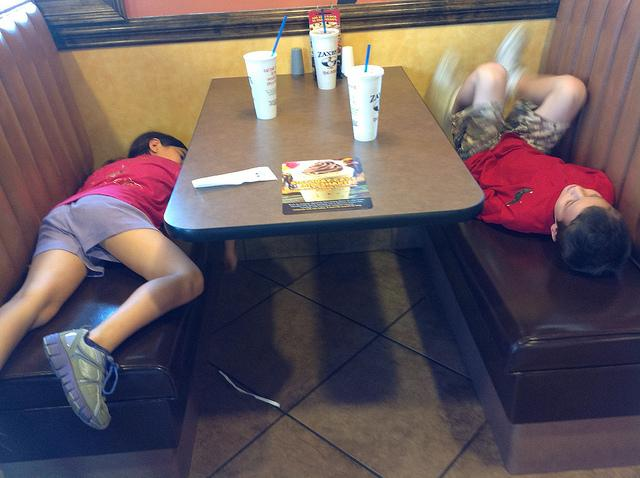Who will pay for this meal?

Choices:
A) parent
B) no one
C) child rightmost
D) leftmost child parent 